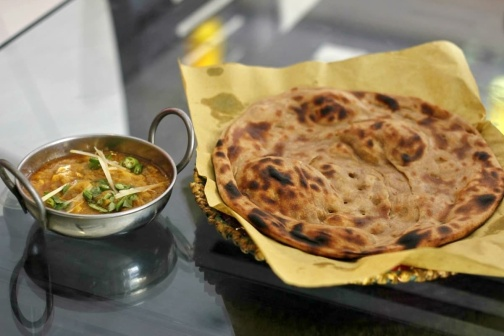Describe a story where this meal is served at a special occasion. In a quaint village during the festival of lights, this meal is the centerpiece of a family gathering. The matriarch of the family has spent hours perfecting the curry, infusing it with generations-old recipes and love. The flatbread, freshly made by the younger members, brings a sense of unity to the gathering. Laughter fills the air as stories are shared, and the aroma of the meal blends with the scent of incense, creating an atmosphere of warmth and nostalgia. The meal symbolizes not just sustenance but a deep connection between family and traditions, harking back to simpler times. What memories could this meal invoke for someone? For someone, this meal could evoke cherished memories of family dinners, where the kitchen buzzed with activity and the fragrance of spices lingered in the air. It might remind them of learning to cook alongside a loved one, tasting the first spoonful of curry and feeling accomplished. It could bring back images of festive celebrations, where the sound of clinking plates and happy conversations were the backdrop to a shared, wholesome meal. Create a whimsical tale where the flatbread is magically alive. In a magical land where food is enchanted, this particular flatbread is not just a meal but a whimsical character. Known as 'Flappy', it has the unique ability to puff up into a balloon-like shape and float around the kitchen. Flappy loves to help with meal preparations, using its puffy form to waft delicious smells throughout the house. On the night of the grand feast, Flappy made sure every dish was perfectly seasoned by adding a dash of this and a sprinkle of that with its floating pirouettes. As the meal was unveiled, Flappy settled back on the yellow paper, content and ready to be a part of a meal that would be remembered by everyone present. 